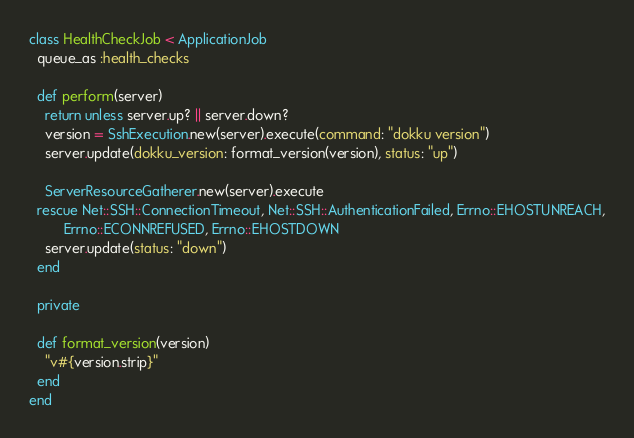<code> <loc_0><loc_0><loc_500><loc_500><_Ruby_>class HealthCheckJob < ApplicationJob
  queue_as :health_checks

  def perform(server)
    return unless server.up? || server.down?
    version = SshExecution.new(server).execute(command: "dokku version")
    server.update(dokku_version: format_version(version), status: "up")

    ServerResourceGatherer.new(server).execute
  rescue Net::SSH::ConnectionTimeout, Net::SSH::AuthenticationFailed, Errno::EHOSTUNREACH,
         Errno::ECONNREFUSED, Errno::EHOSTDOWN
    server.update(status: "down")
  end

  private

  def format_version(version)
    "v#{version.strip}"
  end
end
</code> 